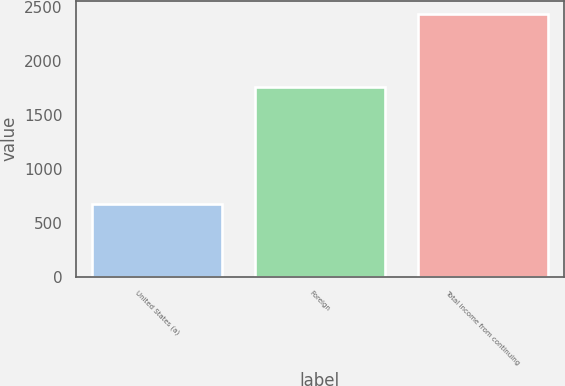<chart> <loc_0><loc_0><loc_500><loc_500><bar_chart><fcel>United States (a)<fcel>Foreign<fcel>Total income from continuing<nl><fcel>676<fcel>1760<fcel>2436<nl></chart> 